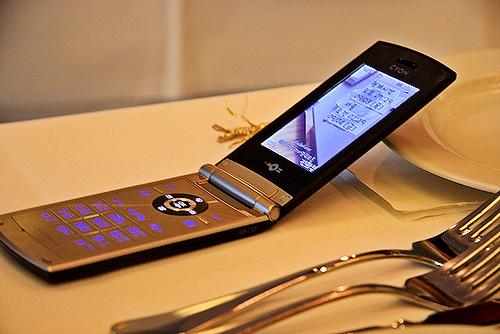How many electronic devices are there?
Concise answer only. 1. Is this office equipment?
Concise answer only. No. What is the name of the music artist that display on the MP3 player that is on the table?
Give a very brief answer. None. Does this phone work properly?
Give a very brief answer. Yes. Is the phone in a case?
Concise answer only. No. Is the phone's battery about to die?
Answer briefly. No. What color is the phone?
Be succinct. Silver. What is the product in?
Quick response, please. Cell phone. How many electronics are in this photo?
Keep it brief. 1. Are the forks to the left or to the right of the phone?
Concise answer only. Right. Is the phone on?
Quick response, please. Yes. 